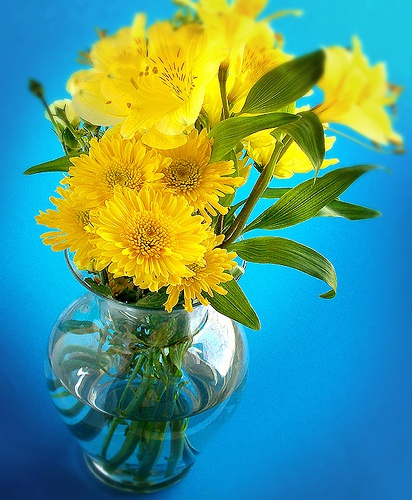Describe the objects in this image and their specific colors. I can see a vase in gray, teal, darkgreen, and black tones in this image. 